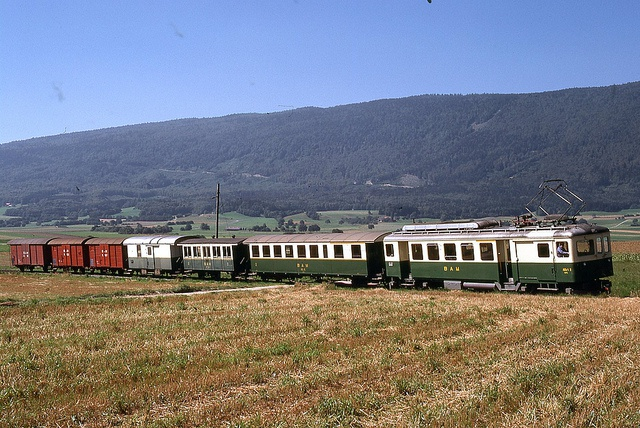Describe the objects in this image and their specific colors. I can see train in lightblue, black, white, gray, and darkgray tones and people in lightblue, black, gray, and violet tones in this image. 